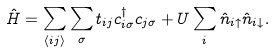Convert formula to latex. <formula><loc_0><loc_0><loc_500><loc_500>\hat { H } = \sum _ { \langle i j \rangle } \sum _ { \sigma } t _ { i j } c ^ { \dagger } _ { i \sigma } c _ { j \sigma } + U \sum _ { i } \hat { n } _ { i \uparrow } \hat { n } _ { i \downarrow } .</formula> 